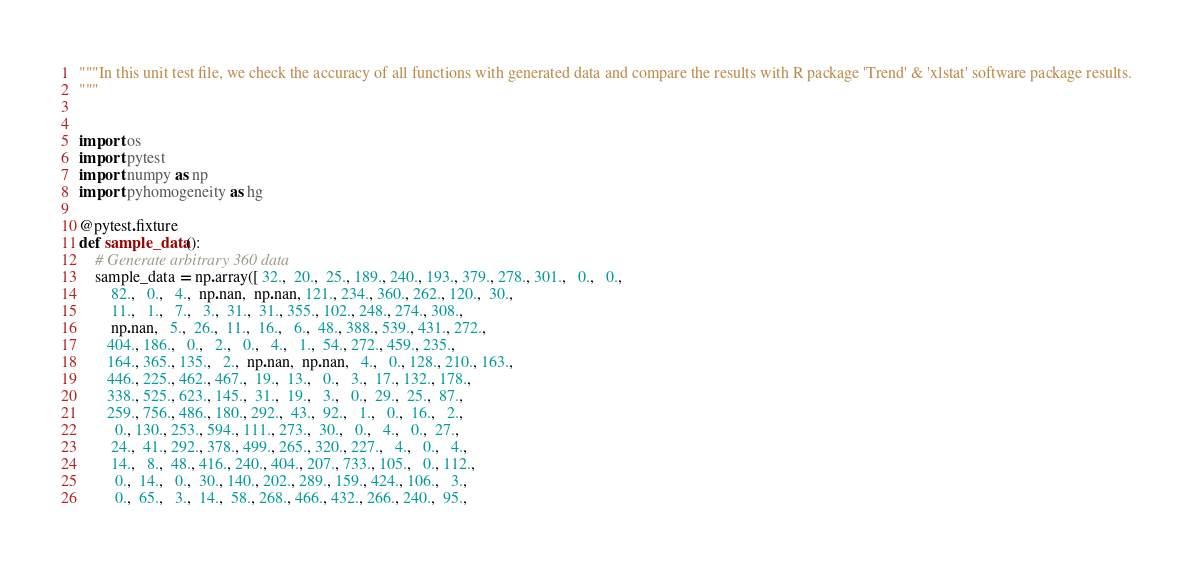Convert code to text. <code><loc_0><loc_0><loc_500><loc_500><_Python_>"""In this unit test file, we check the accuracy of all functions with generated data and compare the results with R package 'Trend' & 'xlstat' software package results.
"""


import os
import pytest
import numpy as np
import pyhomogeneity as hg

@pytest.fixture
def sample_data():
    # Generate arbitrary 360 data
    sample_data = np.array([ 32.,  20.,  25., 189., 240., 193., 379., 278., 301.,   0.,   0.,
        82.,   0.,   4.,  np.nan,  np.nan, 121., 234., 360., 262., 120.,  30.,
        11.,   1.,   7.,   3.,  31.,  31., 355., 102., 248., 274., 308.,
        np.nan,   5.,  26.,  11.,  16.,   6.,  48., 388., 539., 431., 272.,
       404., 186.,   0.,   2.,   0.,   4.,   1.,  54., 272., 459., 235.,
       164., 365., 135.,   2.,  np.nan,  np.nan,   4.,   0., 128., 210., 163.,
       446., 225., 462., 467.,  19.,  13.,   0.,   3.,  17., 132., 178.,
       338., 525., 623., 145.,  31.,  19.,   3.,   0.,  29.,  25.,  87.,
       259., 756., 486., 180., 292.,  43.,  92.,   1.,   0.,  16.,   2.,
         0., 130., 253., 594., 111., 273.,  30.,   0.,   4.,   0.,  27.,
        24.,  41., 292., 378., 499., 265., 320., 227.,   4.,   0.,   4.,
        14.,   8.,  48., 416., 240., 404., 207., 733., 105.,   0., 112.,
         0.,  14.,   0.,  30., 140., 202., 289., 159., 424., 106.,   3.,
         0.,  65.,   3.,  14.,  58., 268., 466., 432., 266., 240.,  95.,</code> 